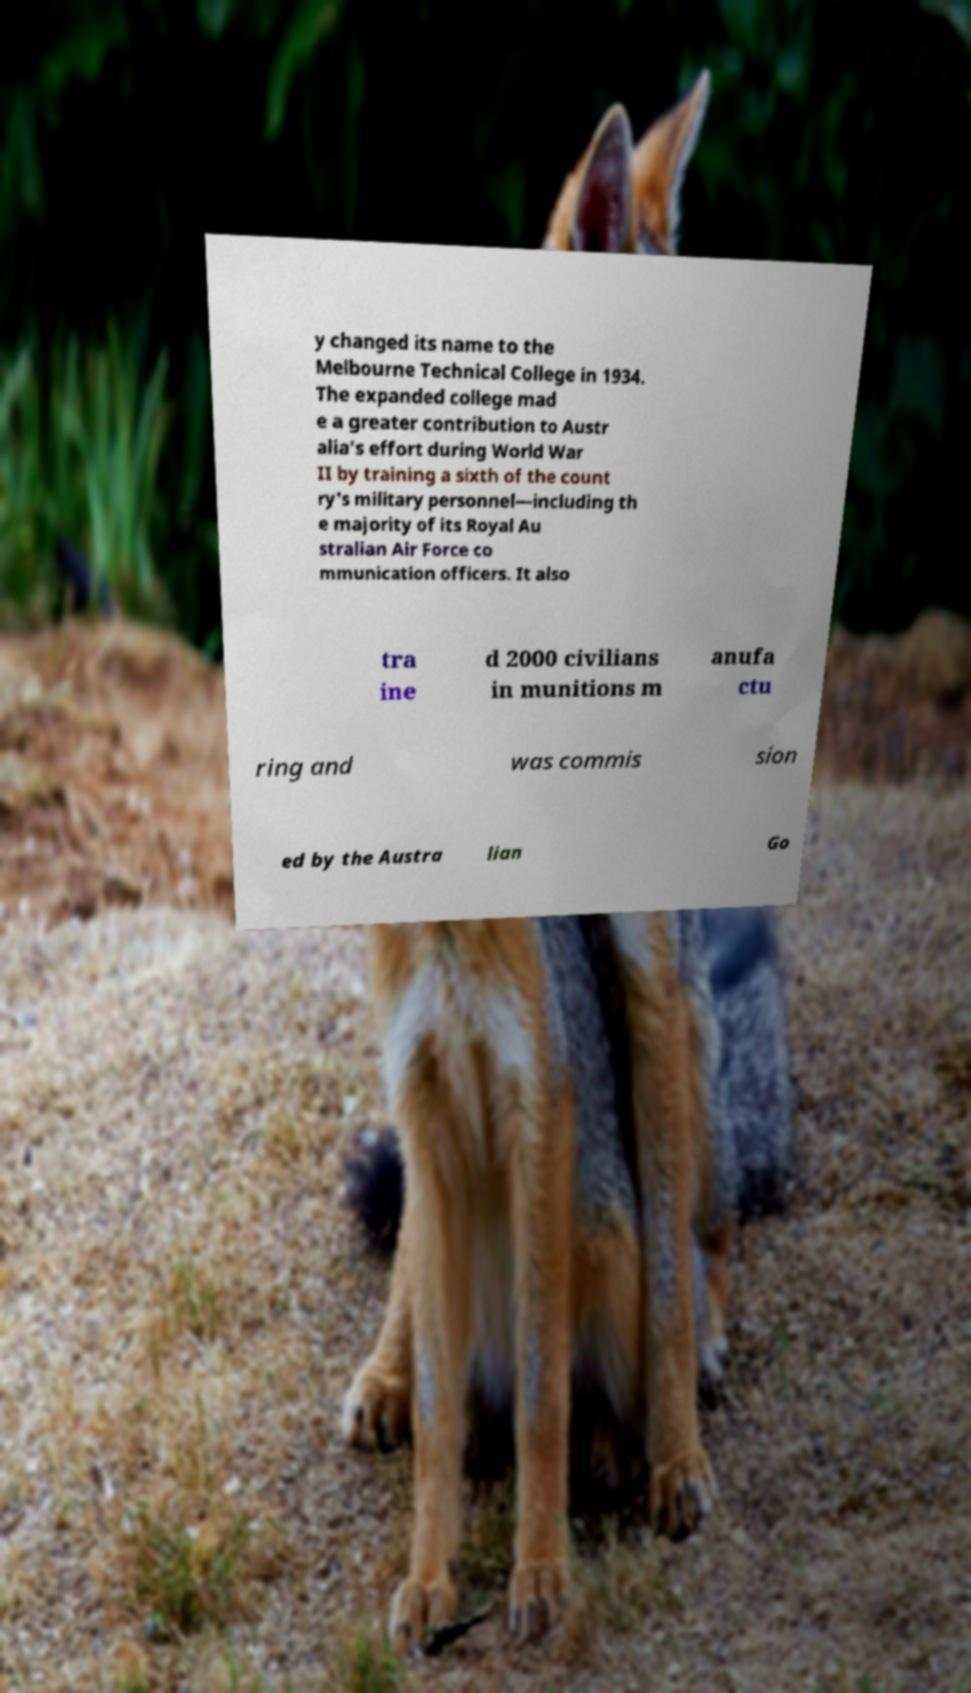What messages or text are displayed in this image? I need them in a readable, typed format. y changed its name to the Melbourne Technical College in 1934. The expanded college mad e a greater contribution to Austr alia's effort during World War II by training a sixth of the count ry's military personnel—including th e majority of its Royal Au stralian Air Force co mmunication officers. It also tra ine d 2000 civilians in munitions m anufa ctu ring and was commis sion ed by the Austra lian Go 